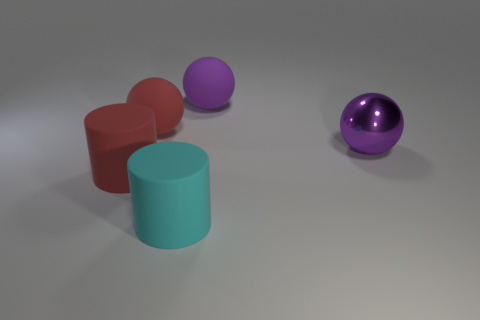There is a large cyan object that is made of the same material as the large red sphere; what shape is it?
Your response must be concise. Cylinder. There is a large red thing in front of the metal object; what shape is it?
Your answer should be compact. Cylinder. The red ball that is made of the same material as the red cylinder is what size?
Give a very brief answer. Large. What is the shape of the big thing that is to the right of the cyan cylinder and on the left side of the shiny sphere?
Give a very brief answer. Sphere. There is a large rubber ball right of the large cyan cylinder; is it the same color as the shiny ball?
Your response must be concise. Yes. Does the big purple rubber thing that is behind the cyan cylinder have the same shape as the purple object in front of the purple matte sphere?
Give a very brief answer. Yes. There is a cylinder that is behind the cyan cylinder; what size is it?
Keep it short and to the point. Large. Is the number of purple matte spheres greater than the number of purple things?
Keep it short and to the point. No. Is the number of large cyan things right of the big red rubber cylinder greater than the number of rubber cylinders that are in front of the metallic object?
Provide a short and direct response. No. What number of other shiny spheres have the same size as the red sphere?
Your response must be concise. 1. 